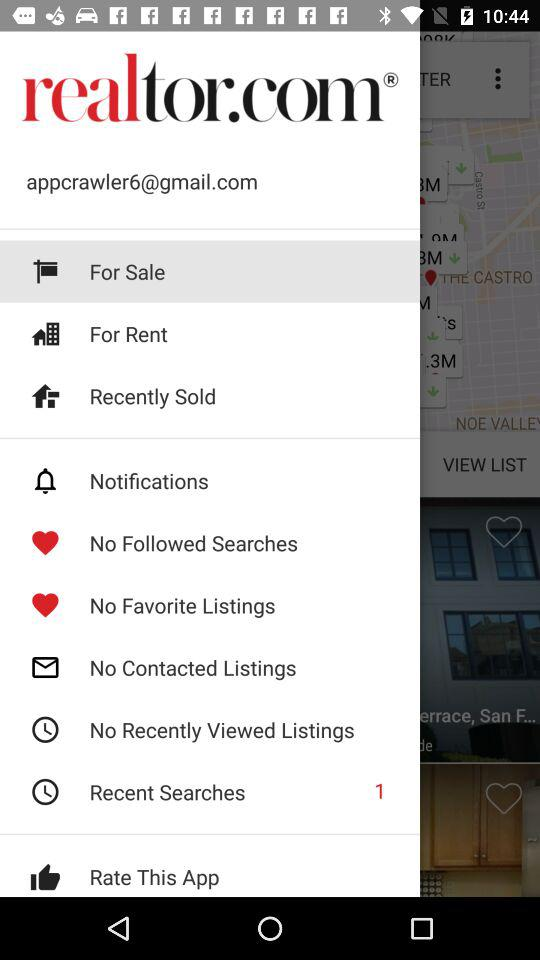What is the email address? The email address is appcrawler6@gmail.com. 